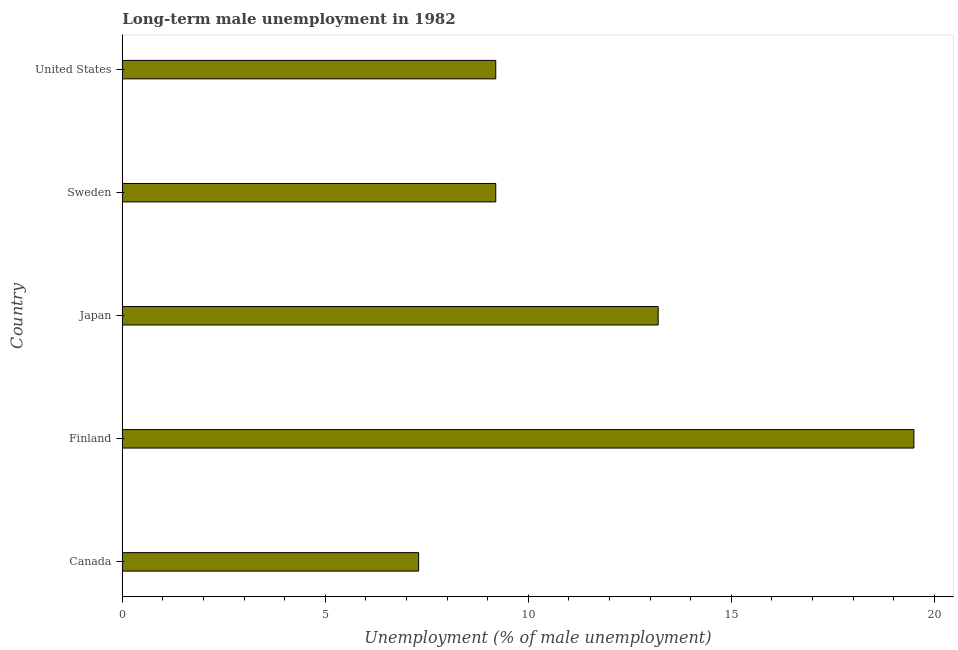Does the graph contain grids?
Offer a terse response. No. What is the title of the graph?
Give a very brief answer. Long-term male unemployment in 1982. What is the label or title of the X-axis?
Provide a succinct answer. Unemployment (% of male unemployment). What is the long-term male unemployment in United States?
Your answer should be compact. 9.2. Across all countries, what is the maximum long-term male unemployment?
Offer a very short reply. 19.5. Across all countries, what is the minimum long-term male unemployment?
Provide a succinct answer. 7.3. What is the sum of the long-term male unemployment?
Keep it short and to the point. 58.4. What is the average long-term male unemployment per country?
Offer a very short reply. 11.68. What is the median long-term male unemployment?
Ensure brevity in your answer.  9.2. What is the ratio of the long-term male unemployment in Japan to that in Sweden?
Make the answer very short. 1.44. Is the long-term male unemployment in Finland less than that in Sweden?
Give a very brief answer. No. Is the sum of the long-term male unemployment in Finland and Japan greater than the maximum long-term male unemployment across all countries?
Your response must be concise. Yes. In how many countries, is the long-term male unemployment greater than the average long-term male unemployment taken over all countries?
Give a very brief answer. 2. How many countries are there in the graph?
Ensure brevity in your answer.  5. What is the Unemployment (% of male unemployment) of Canada?
Offer a very short reply. 7.3. What is the Unemployment (% of male unemployment) of Finland?
Your answer should be compact. 19.5. What is the Unemployment (% of male unemployment) in Japan?
Your answer should be very brief. 13.2. What is the Unemployment (% of male unemployment) in Sweden?
Your answer should be compact. 9.2. What is the Unemployment (% of male unemployment) in United States?
Your answer should be very brief. 9.2. What is the difference between the Unemployment (% of male unemployment) in Canada and Finland?
Offer a terse response. -12.2. What is the difference between the Unemployment (% of male unemployment) in Finland and Japan?
Your response must be concise. 6.3. What is the difference between the Unemployment (% of male unemployment) in Japan and United States?
Your response must be concise. 4. What is the difference between the Unemployment (% of male unemployment) in Sweden and United States?
Keep it short and to the point. 0. What is the ratio of the Unemployment (% of male unemployment) in Canada to that in Finland?
Make the answer very short. 0.37. What is the ratio of the Unemployment (% of male unemployment) in Canada to that in Japan?
Keep it short and to the point. 0.55. What is the ratio of the Unemployment (% of male unemployment) in Canada to that in Sweden?
Give a very brief answer. 0.79. What is the ratio of the Unemployment (% of male unemployment) in Canada to that in United States?
Your answer should be very brief. 0.79. What is the ratio of the Unemployment (% of male unemployment) in Finland to that in Japan?
Provide a short and direct response. 1.48. What is the ratio of the Unemployment (% of male unemployment) in Finland to that in Sweden?
Your response must be concise. 2.12. What is the ratio of the Unemployment (% of male unemployment) in Finland to that in United States?
Provide a succinct answer. 2.12. What is the ratio of the Unemployment (% of male unemployment) in Japan to that in Sweden?
Ensure brevity in your answer.  1.44. What is the ratio of the Unemployment (% of male unemployment) in Japan to that in United States?
Offer a very short reply. 1.44. What is the ratio of the Unemployment (% of male unemployment) in Sweden to that in United States?
Your answer should be compact. 1. 